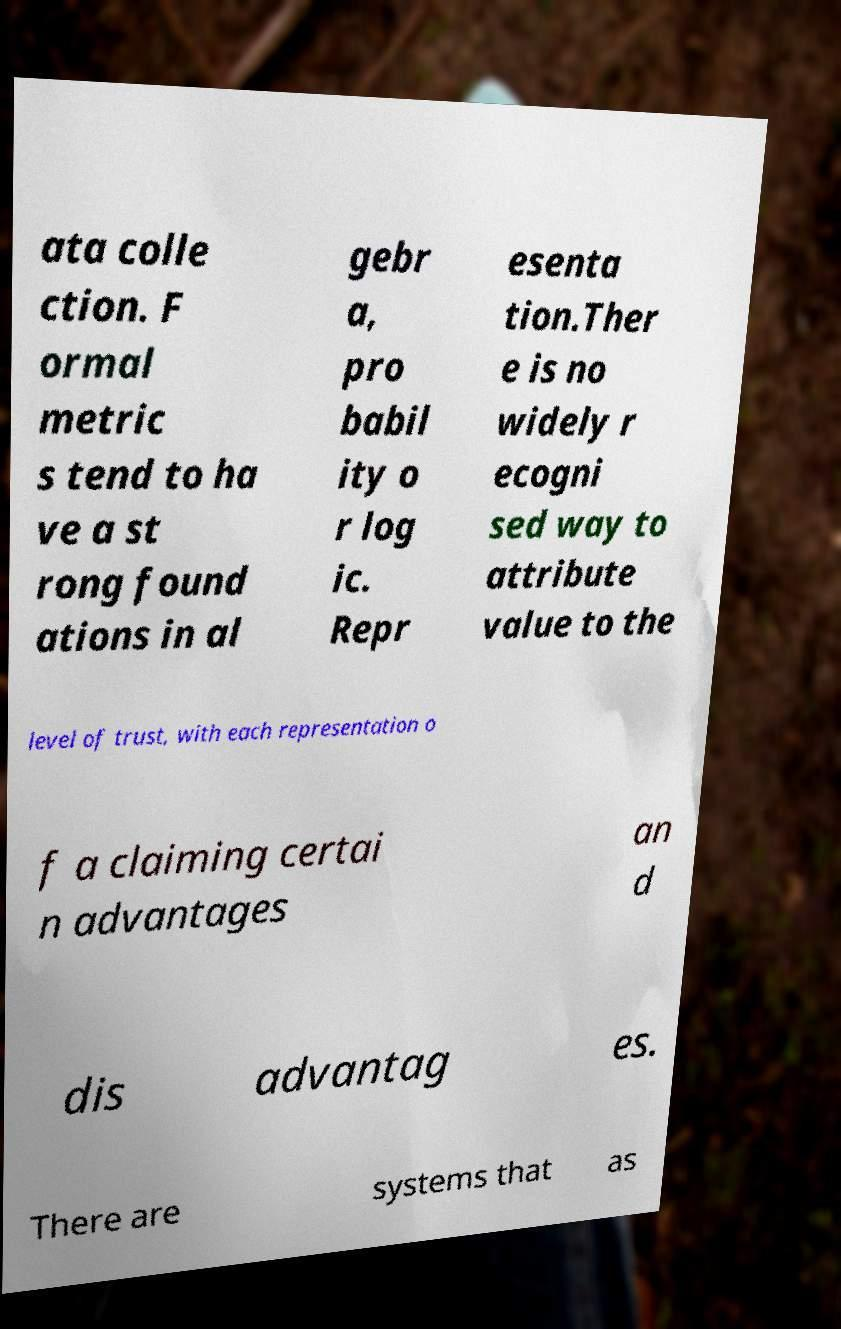Could you assist in decoding the text presented in this image and type it out clearly? ata colle ction. F ormal metric s tend to ha ve a st rong found ations in al gebr a, pro babil ity o r log ic. Repr esenta tion.Ther e is no widely r ecogni sed way to attribute value to the level of trust, with each representation o f a claiming certai n advantages an d dis advantag es. There are systems that as 